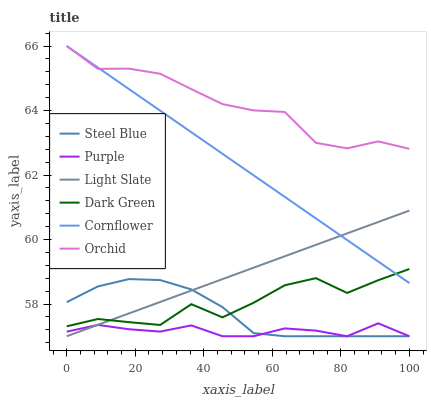Does Purple have the minimum area under the curve?
Answer yes or no. Yes. Does Orchid have the maximum area under the curve?
Answer yes or no. Yes. Does Steel Blue have the minimum area under the curve?
Answer yes or no. No. Does Steel Blue have the maximum area under the curve?
Answer yes or no. No. Is Light Slate the smoothest?
Answer yes or no. Yes. Is Dark Green the roughest?
Answer yes or no. Yes. Is Purple the smoothest?
Answer yes or no. No. Is Purple the roughest?
Answer yes or no. No. Does Dark Green have the lowest value?
Answer yes or no. No. Does Steel Blue have the highest value?
Answer yes or no. No. Is Dark Green less than Orchid?
Answer yes or no. Yes. Is Orchid greater than Dark Green?
Answer yes or no. Yes. Does Dark Green intersect Orchid?
Answer yes or no. No. 